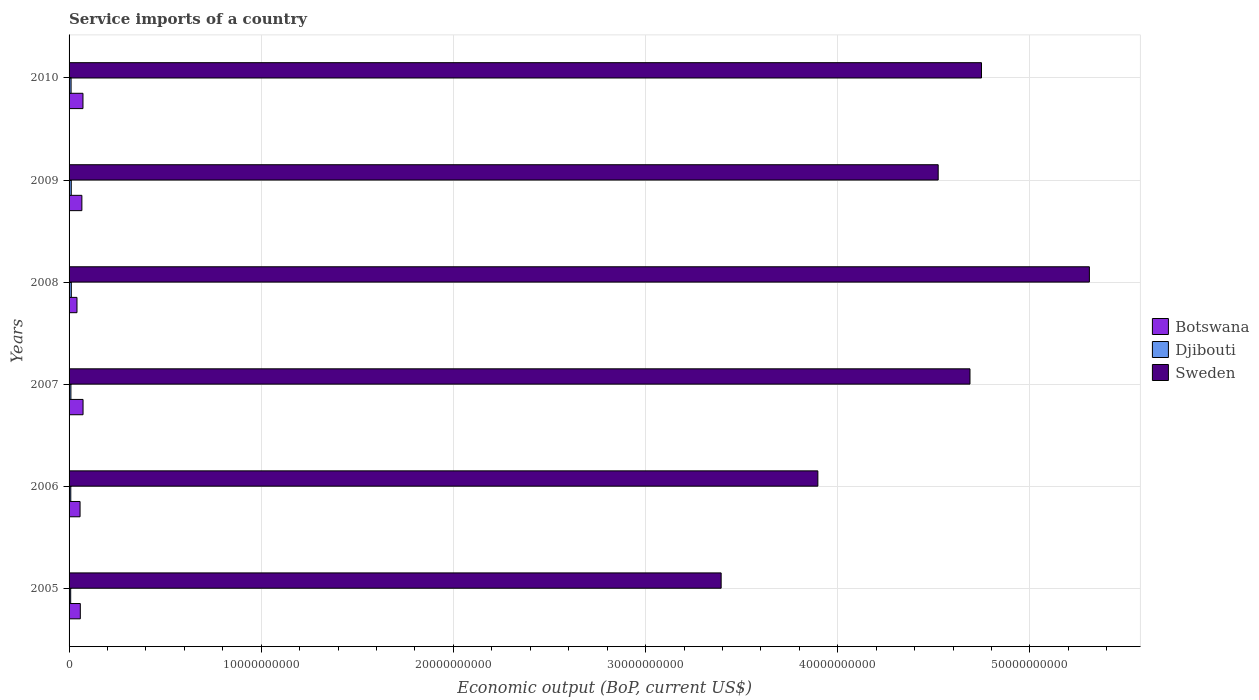How many groups of bars are there?
Your answer should be compact. 6. Are the number of bars on each tick of the Y-axis equal?
Provide a short and direct response. Yes. How many bars are there on the 3rd tick from the top?
Give a very brief answer. 3. How many bars are there on the 3rd tick from the bottom?
Provide a succinct answer. 3. What is the label of the 5th group of bars from the top?
Provide a succinct answer. 2006. In how many cases, is the number of bars for a given year not equal to the number of legend labels?
Your answer should be compact. 0. What is the service imports in Sweden in 2007?
Your answer should be compact. 4.69e+1. Across all years, what is the maximum service imports in Djibouti?
Your response must be concise. 1.17e+08. Across all years, what is the minimum service imports in Sweden?
Your answer should be compact. 3.39e+1. What is the total service imports in Sweden in the graph?
Give a very brief answer. 2.66e+11. What is the difference between the service imports in Djibouti in 2008 and that in 2010?
Give a very brief answer. 1.20e+07. What is the difference between the service imports in Sweden in 2006 and the service imports in Botswana in 2007?
Your answer should be compact. 3.82e+1. What is the average service imports in Sweden per year?
Provide a short and direct response. 4.43e+1. In the year 2005, what is the difference between the service imports in Botswana and service imports in Djibouti?
Offer a terse response. 5.01e+08. In how many years, is the service imports in Djibouti greater than 20000000000 US$?
Provide a short and direct response. 0. What is the ratio of the service imports in Djibouti in 2006 to that in 2010?
Your answer should be compact. 0.85. Is the service imports in Sweden in 2005 less than that in 2008?
Provide a succinct answer. Yes. What is the difference between the highest and the second highest service imports in Botswana?
Give a very brief answer. 4.27e+06. What is the difference between the highest and the lowest service imports in Djibouti?
Offer a terse response. 3.27e+07. What does the 2nd bar from the top in 2008 represents?
Offer a terse response. Djibouti. What does the 2nd bar from the bottom in 2009 represents?
Provide a succinct answer. Djibouti. Are all the bars in the graph horizontal?
Keep it short and to the point. Yes. How many years are there in the graph?
Your answer should be very brief. 6. What is the difference between two consecutive major ticks on the X-axis?
Your response must be concise. 1.00e+1. Where does the legend appear in the graph?
Make the answer very short. Center right. What is the title of the graph?
Offer a terse response. Service imports of a country. Does "Uganda" appear as one of the legend labels in the graph?
Offer a terse response. No. What is the label or title of the X-axis?
Your answer should be compact. Economic output (BoP, current US$). What is the Economic output (BoP, current US$) of Botswana in 2005?
Provide a short and direct response. 5.85e+08. What is the Economic output (BoP, current US$) in Djibouti in 2005?
Provide a succinct answer. 8.38e+07. What is the Economic output (BoP, current US$) of Sweden in 2005?
Your answer should be compact. 3.39e+1. What is the Economic output (BoP, current US$) in Botswana in 2006?
Your answer should be very brief. 5.72e+08. What is the Economic output (BoP, current US$) in Djibouti in 2006?
Give a very brief answer. 8.93e+07. What is the Economic output (BoP, current US$) of Sweden in 2006?
Ensure brevity in your answer.  3.90e+1. What is the Economic output (BoP, current US$) of Botswana in 2007?
Give a very brief answer. 7.27e+08. What is the Economic output (BoP, current US$) in Djibouti in 2007?
Make the answer very short. 9.54e+07. What is the Economic output (BoP, current US$) in Sweden in 2007?
Make the answer very short. 4.69e+1. What is the Economic output (BoP, current US$) in Botswana in 2008?
Your answer should be very brief. 4.12e+08. What is the Economic output (BoP, current US$) of Djibouti in 2008?
Offer a terse response. 1.17e+08. What is the Economic output (BoP, current US$) in Sweden in 2008?
Your answer should be very brief. 5.31e+1. What is the Economic output (BoP, current US$) in Botswana in 2009?
Provide a succinct answer. 6.67e+08. What is the Economic output (BoP, current US$) of Djibouti in 2009?
Give a very brief answer. 1.14e+08. What is the Economic output (BoP, current US$) of Sweden in 2009?
Provide a short and direct response. 4.52e+1. What is the Economic output (BoP, current US$) in Botswana in 2010?
Make the answer very short. 7.23e+08. What is the Economic output (BoP, current US$) of Djibouti in 2010?
Your answer should be compact. 1.05e+08. What is the Economic output (BoP, current US$) in Sweden in 2010?
Your response must be concise. 4.75e+1. Across all years, what is the maximum Economic output (BoP, current US$) in Botswana?
Provide a short and direct response. 7.27e+08. Across all years, what is the maximum Economic output (BoP, current US$) of Djibouti?
Your response must be concise. 1.17e+08. Across all years, what is the maximum Economic output (BoP, current US$) of Sweden?
Give a very brief answer. 5.31e+1. Across all years, what is the minimum Economic output (BoP, current US$) of Botswana?
Offer a terse response. 4.12e+08. Across all years, what is the minimum Economic output (BoP, current US$) of Djibouti?
Your answer should be very brief. 8.38e+07. Across all years, what is the minimum Economic output (BoP, current US$) of Sweden?
Your response must be concise. 3.39e+1. What is the total Economic output (BoP, current US$) of Botswana in the graph?
Provide a succinct answer. 3.68e+09. What is the total Economic output (BoP, current US$) of Djibouti in the graph?
Make the answer very short. 6.03e+08. What is the total Economic output (BoP, current US$) of Sweden in the graph?
Make the answer very short. 2.66e+11. What is the difference between the Economic output (BoP, current US$) of Botswana in 2005 and that in 2006?
Provide a succinct answer. 1.32e+07. What is the difference between the Economic output (BoP, current US$) of Djibouti in 2005 and that in 2006?
Provide a short and direct response. -5.48e+06. What is the difference between the Economic output (BoP, current US$) of Sweden in 2005 and that in 2006?
Offer a terse response. -5.03e+09. What is the difference between the Economic output (BoP, current US$) in Botswana in 2005 and that in 2007?
Provide a succinct answer. -1.42e+08. What is the difference between the Economic output (BoP, current US$) of Djibouti in 2005 and that in 2007?
Your response must be concise. -1.16e+07. What is the difference between the Economic output (BoP, current US$) in Sweden in 2005 and that in 2007?
Provide a short and direct response. -1.29e+1. What is the difference between the Economic output (BoP, current US$) in Botswana in 2005 and that in 2008?
Keep it short and to the point. 1.73e+08. What is the difference between the Economic output (BoP, current US$) in Djibouti in 2005 and that in 2008?
Ensure brevity in your answer.  -3.27e+07. What is the difference between the Economic output (BoP, current US$) of Sweden in 2005 and that in 2008?
Offer a very short reply. -1.92e+1. What is the difference between the Economic output (BoP, current US$) in Botswana in 2005 and that in 2009?
Offer a very short reply. -8.16e+07. What is the difference between the Economic output (BoP, current US$) in Djibouti in 2005 and that in 2009?
Your answer should be very brief. -3.02e+07. What is the difference between the Economic output (BoP, current US$) of Sweden in 2005 and that in 2009?
Provide a short and direct response. -1.13e+1. What is the difference between the Economic output (BoP, current US$) of Botswana in 2005 and that in 2010?
Your answer should be compact. -1.38e+08. What is the difference between the Economic output (BoP, current US$) of Djibouti in 2005 and that in 2010?
Keep it short and to the point. -2.08e+07. What is the difference between the Economic output (BoP, current US$) in Sweden in 2005 and that in 2010?
Your answer should be compact. -1.35e+1. What is the difference between the Economic output (BoP, current US$) of Botswana in 2006 and that in 2007?
Offer a terse response. -1.55e+08. What is the difference between the Economic output (BoP, current US$) of Djibouti in 2006 and that in 2007?
Give a very brief answer. -6.10e+06. What is the difference between the Economic output (BoP, current US$) in Sweden in 2006 and that in 2007?
Offer a terse response. -7.92e+09. What is the difference between the Economic output (BoP, current US$) in Botswana in 2006 and that in 2008?
Keep it short and to the point. 1.60e+08. What is the difference between the Economic output (BoP, current US$) of Djibouti in 2006 and that in 2008?
Provide a succinct answer. -2.72e+07. What is the difference between the Economic output (BoP, current US$) in Sweden in 2006 and that in 2008?
Your answer should be very brief. -1.41e+1. What is the difference between the Economic output (BoP, current US$) of Botswana in 2006 and that in 2009?
Provide a succinct answer. -9.48e+07. What is the difference between the Economic output (BoP, current US$) in Djibouti in 2006 and that in 2009?
Provide a short and direct response. -2.47e+07. What is the difference between the Economic output (BoP, current US$) of Sweden in 2006 and that in 2009?
Offer a terse response. -6.26e+09. What is the difference between the Economic output (BoP, current US$) in Botswana in 2006 and that in 2010?
Give a very brief answer. -1.51e+08. What is the difference between the Economic output (BoP, current US$) in Djibouti in 2006 and that in 2010?
Keep it short and to the point. -1.53e+07. What is the difference between the Economic output (BoP, current US$) of Sweden in 2006 and that in 2010?
Offer a terse response. -8.51e+09. What is the difference between the Economic output (BoP, current US$) in Botswana in 2007 and that in 2008?
Offer a very short reply. 3.16e+08. What is the difference between the Economic output (BoP, current US$) of Djibouti in 2007 and that in 2008?
Provide a succinct answer. -2.11e+07. What is the difference between the Economic output (BoP, current US$) in Sweden in 2007 and that in 2008?
Offer a terse response. -6.21e+09. What is the difference between the Economic output (BoP, current US$) of Botswana in 2007 and that in 2009?
Ensure brevity in your answer.  6.05e+07. What is the difference between the Economic output (BoP, current US$) of Djibouti in 2007 and that in 2009?
Provide a short and direct response. -1.86e+07. What is the difference between the Economic output (BoP, current US$) in Sweden in 2007 and that in 2009?
Your response must be concise. 1.65e+09. What is the difference between the Economic output (BoP, current US$) of Botswana in 2007 and that in 2010?
Offer a terse response. 4.27e+06. What is the difference between the Economic output (BoP, current US$) of Djibouti in 2007 and that in 2010?
Your answer should be very brief. -9.17e+06. What is the difference between the Economic output (BoP, current US$) of Sweden in 2007 and that in 2010?
Your answer should be compact. -5.99e+08. What is the difference between the Economic output (BoP, current US$) in Botswana in 2008 and that in 2009?
Your response must be concise. -2.55e+08. What is the difference between the Economic output (BoP, current US$) in Djibouti in 2008 and that in 2009?
Your answer should be very brief. 2.54e+06. What is the difference between the Economic output (BoP, current US$) of Sweden in 2008 and that in 2009?
Keep it short and to the point. 7.87e+09. What is the difference between the Economic output (BoP, current US$) of Botswana in 2008 and that in 2010?
Provide a succinct answer. -3.11e+08. What is the difference between the Economic output (BoP, current US$) in Djibouti in 2008 and that in 2010?
Make the answer very short. 1.20e+07. What is the difference between the Economic output (BoP, current US$) in Sweden in 2008 and that in 2010?
Ensure brevity in your answer.  5.61e+09. What is the difference between the Economic output (BoP, current US$) of Botswana in 2009 and that in 2010?
Your answer should be compact. -5.62e+07. What is the difference between the Economic output (BoP, current US$) in Djibouti in 2009 and that in 2010?
Keep it short and to the point. 9.42e+06. What is the difference between the Economic output (BoP, current US$) of Sweden in 2009 and that in 2010?
Provide a short and direct response. -2.25e+09. What is the difference between the Economic output (BoP, current US$) of Botswana in 2005 and the Economic output (BoP, current US$) of Djibouti in 2006?
Make the answer very short. 4.96e+08. What is the difference between the Economic output (BoP, current US$) in Botswana in 2005 and the Economic output (BoP, current US$) in Sweden in 2006?
Offer a terse response. -3.84e+1. What is the difference between the Economic output (BoP, current US$) in Djibouti in 2005 and the Economic output (BoP, current US$) in Sweden in 2006?
Your answer should be compact. -3.89e+1. What is the difference between the Economic output (BoP, current US$) of Botswana in 2005 and the Economic output (BoP, current US$) of Djibouti in 2007?
Give a very brief answer. 4.90e+08. What is the difference between the Economic output (BoP, current US$) of Botswana in 2005 and the Economic output (BoP, current US$) of Sweden in 2007?
Your response must be concise. -4.63e+1. What is the difference between the Economic output (BoP, current US$) of Djibouti in 2005 and the Economic output (BoP, current US$) of Sweden in 2007?
Make the answer very short. -4.68e+1. What is the difference between the Economic output (BoP, current US$) in Botswana in 2005 and the Economic output (BoP, current US$) in Djibouti in 2008?
Keep it short and to the point. 4.68e+08. What is the difference between the Economic output (BoP, current US$) in Botswana in 2005 and the Economic output (BoP, current US$) in Sweden in 2008?
Your answer should be very brief. -5.25e+1. What is the difference between the Economic output (BoP, current US$) of Djibouti in 2005 and the Economic output (BoP, current US$) of Sweden in 2008?
Give a very brief answer. -5.30e+1. What is the difference between the Economic output (BoP, current US$) in Botswana in 2005 and the Economic output (BoP, current US$) in Djibouti in 2009?
Your response must be concise. 4.71e+08. What is the difference between the Economic output (BoP, current US$) in Botswana in 2005 and the Economic output (BoP, current US$) in Sweden in 2009?
Your answer should be very brief. -4.46e+1. What is the difference between the Economic output (BoP, current US$) of Djibouti in 2005 and the Economic output (BoP, current US$) of Sweden in 2009?
Your answer should be compact. -4.51e+1. What is the difference between the Economic output (BoP, current US$) of Botswana in 2005 and the Economic output (BoP, current US$) of Djibouti in 2010?
Your answer should be very brief. 4.80e+08. What is the difference between the Economic output (BoP, current US$) in Botswana in 2005 and the Economic output (BoP, current US$) in Sweden in 2010?
Make the answer very short. -4.69e+1. What is the difference between the Economic output (BoP, current US$) of Djibouti in 2005 and the Economic output (BoP, current US$) of Sweden in 2010?
Make the answer very short. -4.74e+1. What is the difference between the Economic output (BoP, current US$) of Botswana in 2006 and the Economic output (BoP, current US$) of Djibouti in 2007?
Offer a very short reply. 4.76e+08. What is the difference between the Economic output (BoP, current US$) of Botswana in 2006 and the Economic output (BoP, current US$) of Sweden in 2007?
Your answer should be compact. -4.63e+1. What is the difference between the Economic output (BoP, current US$) of Djibouti in 2006 and the Economic output (BoP, current US$) of Sweden in 2007?
Give a very brief answer. -4.68e+1. What is the difference between the Economic output (BoP, current US$) in Botswana in 2006 and the Economic output (BoP, current US$) in Djibouti in 2008?
Offer a very short reply. 4.55e+08. What is the difference between the Economic output (BoP, current US$) in Botswana in 2006 and the Economic output (BoP, current US$) in Sweden in 2008?
Your answer should be very brief. -5.25e+1. What is the difference between the Economic output (BoP, current US$) of Djibouti in 2006 and the Economic output (BoP, current US$) of Sweden in 2008?
Make the answer very short. -5.30e+1. What is the difference between the Economic output (BoP, current US$) in Botswana in 2006 and the Economic output (BoP, current US$) in Djibouti in 2009?
Provide a short and direct response. 4.58e+08. What is the difference between the Economic output (BoP, current US$) of Botswana in 2006 and the Economic output (BoP, current US$) of Sweden in 2009?
Give a very brief answer. -4.47e+1. What is the difference between the Economic output (BoP, current US$) in Djibouti in 2006 and the Economic output (BoP, current US$) in Sweden in 2009?
Provide a short and direct response. -4.51e+1. What is the difference between the Economic output (BoP, current US$) in Botswana in 2006 and the Economic output (BoP, current US$) in Djibouti in 2010?
Keep it short and to the point. 4.67e+08. What is the difference between the Economic output (BoP, current US$) of Botswana in 2006 and the Economic output (BoP, current US$) of Sweden in 2010?
Keep it short and to the point. -4.69e+1. What is the difference between the Economic output (BoP, current US$) in Djibouti in 2006 and the Economic output (BoP, current US$) in Sweden in 2010?
Offer a terse response. -4.74e+1. What is the difference between the Economic output (BoP, current US$) of Botswana in 2007 and the Economic output (BoP, current US$) of Djibouti in 2008?
Provide a short and direct response. 6.11e+08. What is the difference between the Economic output (BoP, current US$) of Botswana in 2007 and the Economic output (BoP, current US$) of Sweden in 2008?
Ensure brevity in your answer.  -5.24e+1. What is the difference between the Economic output (BoP, current US$) in Djibouti in 2007 and the Economic output (BoP, current US$) in Sweden in 2008?
Your answer should be compact. -5.30e+1. What is the difference between the Economic output (BoP, current US$) in Botswana in 2007 and the Economic output (BoP, current US$) in Djibouti in 2009?
Provide a short and direct response. 6.13e+08. What is the difference between the Economic output (BoP, current US$) of Botswana in 2007 and the Economic output (BoP, current US$) of Sweden in 2009?
Offer a very short reply. -4.45e+1. What is the difference between the Economic output (BoP, current US$) in Djibouti in 2007 and the Economic output (BoP, current US$) in Sweden in 2009?
Provide a succinct answer. -4.51e+1. What is the difference between the Economic output (BoP, current US$) of Botswana in 2007 and the Economic output (BoP, current US$) of Djibouti in 2010?
Your answer should be very brief. 6.23e+08. What is the difference between the Economic output (BoP, current US$) of Botswana in 2007 and the Economic output (BoP, current US$) of Sweden in 2010?
Make the answer very short. -4.68e+1. What is the difference between the Economic output (BoP, current US$) of Djibouti in 2007 and the Economic output (BoP, current US$) of Sweden in 2010?
Keep it short and to the point. -4.74e+1. What is the difference between the Economic output (BoP, current US$) in Botswana in 2008 and the Economic output (BoP, current US$) in Djibouti in 2009?
Give a very brief answer. 2.98e+08. What is the difference between the Economic output (BoP, current US$) in Botswana in 2008 and the Economic output (BoP, current US$) in Sweden in 2009?
Provide a succinct answer. -4.48e+1. What is the difference between the Economic output (BoP, current US$) of Djibouti in 2008 and the Economic output (BoP, current US$) of Sweden in 2009?
Ensure brevity in your answer.  -4.51e+1. What is the difference between the Economic output (BoP, current US$) of Botswana in 2008 and the Economic output (BoP, current US$) of Djibouti in 2010?
Give a very brief answer. 3.07e+08. What is the difference between the Economic output (BoP, current US$) in Botswana in 2008 and the Economic output (BoP, current US$) in Sweden in 2010?
Your response must be concise. -4.71e+1. What is the difference between the Economic output (BoP, current US$) of Djibouti in 2008 and the Economic output (BoP, current US$) of Sweden in 2010?
Keep it short and to the point. -4.74e+1. What is the difference between the Economic output (BoP, current US$) in Botswana in 2009 and the Economic output (BoP, current US$) in Djibouti in 2010?
Your response must be concise. 5.62e+08. What is the difference between the Economic output (BoP, current US$) in Botswana in 2009 and the Economic output (BoP, current US$) in Sweden in 2010?
Provide a short and direct response. -4.68e+1. What is the difference between the Economic output (BoP, current US$) in Djibouti in 2009 and the Economic output (BoP, current US$) in Sweden in 2010?
Provide a succinct answer. -4.74e+1. What is the average Economic output (BoP, current US$) of Botswana per year?
Offer a terse response. 6.14e+08. What is the average Economic output (BoP, current US$) in Djibouti per year?
Provide a short and direct response. 1.01e+08. What is the average Economic output (BoP, current US$) in Sweden per year?
Provide a succinct answer. 4.43e+1. In the year 2005, what is the difference between the Economic output (BoP, current US$) of Botswana and Economic output (BoP, current US$) of Djibouti?
Your answer should be compact. 5.01e+08. In the year 2005, what is the difference between the Economic output (BoP, current US$) of Botswana and Economic output (BoP, current US$) of Sweden?
Your answer should be very brief. -3.33e+1. In the year 2005, what is the difference between the Economic output (BoP, current US$) in Djibouti and Economic output (BoP, current US$) in Sweden?
Provide a succinct answer. -3.38e+1. In the year 2006, what is the difference between the Economic output (BoP, current US$) in Botswana and Economic output (BoP, current US$) in Djibouti?
Offer a terse response. 4.83e+08. In the year 2006, what is the difference between the Economic output (BoP, current US$) of Botswana and Economic output (BoP, current US$) of Sweden?
Provide a short and direct response. -3.84e+1. In the year 2006, what is the difference between the Economic output (BoP, current US$) in Djibouti and Economic output (BoP, current US$) in Sweden?
Keep it short and to the point. -3.89e+1. In the year 2007, what is the difference between the Economic output (BoP, current US$) of Botswana and Economic output (BoP, current US$) of Djibouti?
Provide a succinct answer. 6.32e+08. In the year 2007, what is the difference between the Economic output (BoP, current US$) in Botswana and Economic output (BoP, current US$) in Sweden?
Your answer should be compact. -4.62e+1. In the year 2007, what is the difference between the Economic output (BoP, current US$) of Djibouti and Economic output (BoP, current US$) of Sweden?
Provide a succinct answer. -4.68e+1. In the year 2008, what is the difference between the Economic output (BoP, current US$) in Botswana and Economic output (BoP, current US$) in Djibouti?
Your response must be concise. 2.95e+08. In the year 2008, what is the difference between the Economic output (BoP, current US$) of Botswana and Economic output (BoP, current US$) of Sweden?
Make the answer very short. -5.27e+1. In the year 2008, what is the difference between the Economic output (BoP, current US$) of Djibouti and Economic output (BoP, current US$) of Sweden?
Provide a short and direct response. -5.30e+1. In the year 2009, what is the difference between the Economic output (BoP, current US$) of Botswana and Economic output (BoP, current US$) of Djibouti?
Offer a terse response. 5.53e+08. In the year 2009, what is the difference between the Economic output (BoP, current US$) in Botswana and Economic output (BoP, current US$) in Sweden?
Offer a terse response. -4.46e+1. In the year 2009, what is the difference between the Economic output (BoP, current US$) in Djibouti and Economic output (BoP, current US$) in Sweden?
Your response must be concise. -4.51e+1. In the year 2010, what is the difference between the Economic output (BoP, current US$) in Botswana and Economic output (BoP, current US$) in Djibouti?
Provide a succinct answer. 6.18e+08. In the year 2010, what is the difference between the Economic output (BoP, current US$) of Botswana and Economic output (BoP, current US$) of Sweden?
Provide a short and direct response. -4.68e+1. In the year 2010, what is the difference between the Economic output (BoP, current US$) of Djibouti and Economic output (BoP, current US$) of Sweden?
Keep it short and to the point. -4.74e+1. What is the ratio of the Economic output (BoP, current US$) in Djibouti in 2005 to that in 2006?
Offer a terse response. 0.94. What is the ratio of the Economic output (BoP, current US$) in Sweden in 2005 to that in 2006?
Provide a succinct answer. 0.87. What is the ratio of the Economic output (BoP, current US$) in Botswana in 2005 to that in 2007?
Provide a succinct answer. 0.8. What is the ratio of the Economic output (BoP, current US$) in Djibouti in 2005 to that in 2007?
Provide a short and direct response. 0.88. What is the ratio of the Economic output (BoP, current US$) in Sweden in 2005 to that in 2007?
Your answer should be compact. 0.72. What is the ratio of the Economic output (BoP, current US$) of Botswana in 2005 to that in 2008?
Give a very brief answer. 1.42. What is the ratio of the Economic output (BoP, current US$) of Djibouti in 2005 to that in 2008?
Ensure brevity in your answer.  0.72. What is the ratio of the Economic output (BoP, current US$) in Sweden in 2005 to that in 2008?
Offer a terse response. 0.64. What is the ratio of the Economic output (BoP, current US$) of Botswana in 2005 to that in 2009?
Keep it short and to the point. 0.88. What is the ratio of the Economic output (BoP, current US$) of Djibouti in 2005 to that in 2009?
Give a very brief answer. 0.74. What is the ratio of the Economic output (BoP, current US$) in Sweden in 2005 to that in 2009?
Your response must be concise. 0.75. What is the ratio of the Economic output (BoP, current US$) in Botswana in 2005 to that in 2010?
Keep it short and to the point. 0.81. What is the ratio of the Economic output (BoP, current US$) in Djibouti in 2005 to that in 2010?
Provide a succinct answer. 0.8. What is the ratio of the Economic output (BoP, current US$) of Sweden in 2005 to that in 2010?
Offer a very short reply. 0.71. What is the ratio of the Economic output (BoP, current US$) in Botswana in 2006 to that in 2007?
Keep it short and to the point. 0.79. What is the ratio of the Economic output (BoP, current US$) of Djibouti in 2006 to that in 2007?
Provide a succinct answer. 0.94. What is the ratio of the Economic output (BoP, current US$) of Sweden in 2006 to that in 2007?
Make the answer very short. 0.83. What is the ratio of the Economic output (BoP, current US$) of Botswana in 2006 to that in 2008?
Your response must be concise. 1.39. What is the ratio of the Economic output (BoP, current US$) of Djibouti in 2006 to that in 2008?
Give a very brief answer. 0.77. What is the ratio of the Economic output (BoP, current US$) of Sweden in 2006 to that in 2008?
Keep it short and to the point. 0.73. What is the ratio of the Economic output (BoP, current US$) in Botswana in 2006 to that in 2009?
Your answer should be compact. 0.86. What is the ratio of the Economic output (BoP, current US$) in Djibouti in 2006 to that in 2009?
Offer a terse response. 0.78. What is the ratio of the Economic output (BoP, current US$) of Sweden in 2006 to that in 2009?
Give a very brief answer. 0.86. What is the ratio of the Economic output (BoP, current US$) of Botswana in 2006 to that in 2010?
Keep it short and to the point. 0.79. What is the ratio of the Economic output (BoP, current US$) of Djibouti in 2006 to that in 2010?
Ensure brevity in your answer.  0.85. What is the ratio of the Economic output (BoP, current US$) in Sweden in 2006 to that in 2010?
Your response must be concise. 0.82. What is the ratio of the Economic output (BoP, current US$) in Botswana in 2007 to that in 2008?
Give a very brief answer. 1.77. What is the ratio of the Economic output (BoP, current US$) in Djibouti in 2007 to that in 2008?
Your answer should be very brief. 0.82. What is the ratio of the Economic output (BoP, current US$) in Sweden in 2007 to that in 2008?
Make the answer very short. 0.88. What is the ratio of the Economic output (BoP, current US$) in Botswana in 2007 to that in 2009?
Your answer should be compact. 1.09. What is the ratio of the Economic output (BoP, current US$) in Djibouti in 2007 to that in 2009?
Give a very brief answer. 0.84. What is the ratio of the Economic output (BoP, current US$) in Sweden in 2007 to that in 2009?
Keep it short and to the point. 1.04. What is the ratio of the Economic output (BoP, current US$) of Botswana in 2007 to that in 2010?
Make the answer very short. 1.01. What is the ratio of the Economic output (BoP, current US$) in Djibouti in 2007 to that in 2010?
Your answer should be very brief. 0.91. What is the ratio of the Economic output (BoP, current US$) in Sweden in 2007 to that in 2010?
Your response must be concise. 0.99. What is the ratio of the Economic output (BoP, current US$) of Botswana in 2008 to that in 2009?
Your answer should be compact. 0.62. What is the ratio of the Economic output (BoP, current US$) of Djibouti in 2008 to that in 2009?
Ensure brevity in your answer.  1.02. What is the ratio of the Economic output (BoP, current US$) of Sweden in 2008 to that in 2009?
Make the answer very short. 1.17. What is the ratio of the Economic output (BoP, current US$) in Botswana in 2008 to that in 2010?
Ensure brevity in your answer.  0.57. What is the ratio of the Economic output (BoP, current US$) in Djibouti in 2008 to that in 2010?
Give a very brief answer. 1.11. What is the ratio of the Economic output (BoP, current US$) in Sweden in 2008 to that in 2010?
Your response must be concise. 1.12. What is the ratio of the Economic output (BoP, current US$) in Botswana in 2009 to that in 2010?
Offer a terse response. 0.92. What is the ratio of the Economic output (BoP, current US$) of Djibouti in 2009 to that in 2010?
Offer a very short reply. 1.09. What is the ratio of the Economic output (BoP, current US$) of Sweden in 2009 to that in 2010?
Your answer should be compact. 0.95. What is the difference between the highest and the second highest Economic output (BoP, current US$) of Botswana?
Your response must be concise. 4.27e+06. What is the difference between the highest and the second highest Economic output (BoP, current US$) of Djibouti?
Provide a short and direct response. 2.54e+06. What is the difference between the highest and the second highest Economic output (BoP, current US$) of Sweden?
Give a very brief answer. 5.61e+09. What is the difference between the highest and the lowest Economic output (BoP, current US$) in Botswana?
Your answer should be compact. 3.16e+08. What is the difference between the highest and the lowest Economic output (BoP, current US$) of Djibouti?
Make the answer very short. 3.27e+07. What is the difference between the highest and the lowest Economic output (BoP, current US$) of Sweden?
Offer a very short reply. 1.92e+1. 